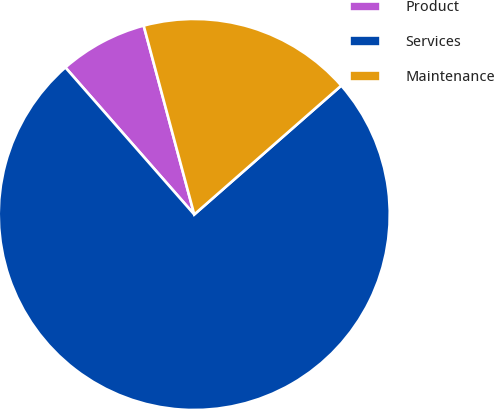<chart> <loc_0><loc_0><loc_500><loc_500><pie_chart><fcel>Product<fcel>Services<fcel>Maintenance<nl><fcel>7.29%<fcel>75.0%<fcel>17.71%<nl></chart> 